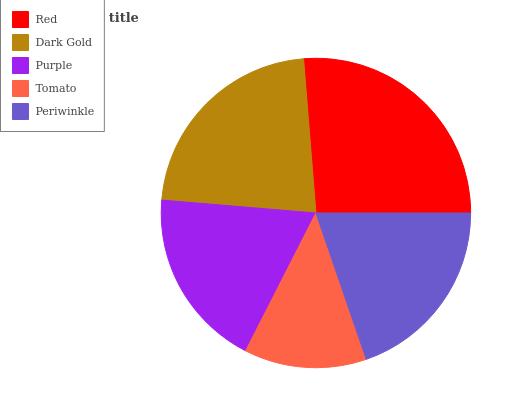Is Tomato the minimum?
Answer yes or no. Yes. Is Red the maximum?
Answer yes or no. Yes. Is Dark Gold the minimum?
Answer yes or no. No. Is Dark Gold the maximum?
Answer yes or no. No. Is Red greater than Dark Gold?
Answer yes or no. Yes. Is Dark Gold less than Red?
Answer yes or no. Yes. Is Dark Gold greater than Red?
Answer yes or no. No. Is Red less than Dark Gold?
Answer yes or no. No. Is Periwinkle the high median?
Answer yes or no. Yes. Is Periwinkle the low median?
Answer yes or no. Yes. Is Purple the high median?
Answer yes or no. No. Is Dark Gold the low median?
Answer yes or no. No. 